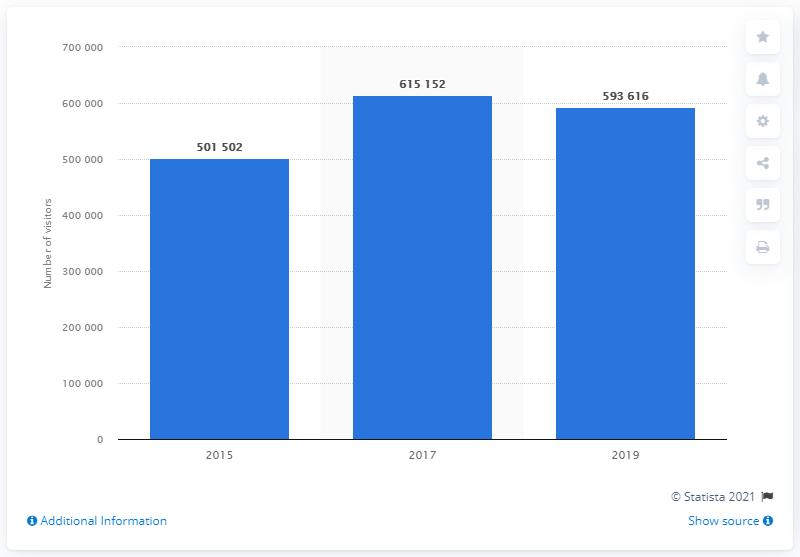Outline some significant characteristics in this image. The 58th edition of the Biennale was attended by a total of 593,616 visitors. 